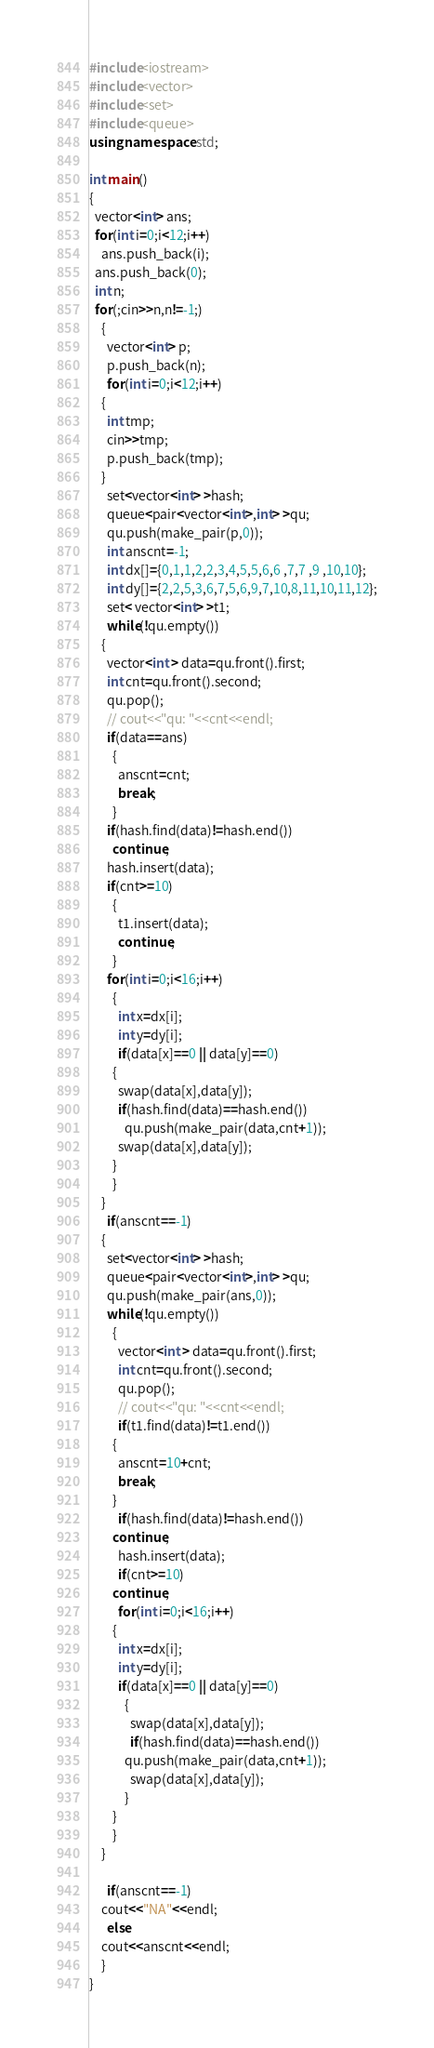<code> <loc_0><loc_0><loc_500><loc_500><_C++_>#include<iostream>
#include<vector>
#include<set>
#include<queue>
using namespace std;

int main()
{
  vector<int> ans;
  for(int i=0;i<12;i++)
    ans.push_back(i);
  ans.push_back(0);
  int n;
  for(;cin>>n,n!=-1;)
    {
      vector<int> p;
      p.push_back(n);
      for(int i=0;i<12;i++)
	{
	  int tmp;
	  cin>>tmp;
	  p.push_back(tmp);
	}
      set<vector<int> >hash;
      queue<pair<vector<int>,int> >qu;
      qu.push(make_pair(p,0));
      int anscnt=-1;
      int dx[]={0,1,1,2,2,3,4,5,5,6,6 ,7,7 ,9 ,10,10};
      int dy[]={2,2,5,3,6,7,5,6,9,7,10,8,11,10,11,12};
      set< vector<int> >t1;
      while(!qu.empty())
	{
	  vector<int > data=qu.front().first;
	  int cnt=qu.front().second;
	  qu.pop();
	  // cout<<"qu: "<<cnt<<endl;
	  if(data==ans)
	    {
	      anscnt=cnt;
	      break;
	    }
	  if(hash.find(data)!=hash.end())
	    continue;
	  hash.insert(data);
	  if(cnt>=10)
	    {
	      t1.insert(data);
	      continue;
	    }
	  for(int i=0;i<16;i++)
	    {
	      int x=dx[i];
	      int y=dy[i];
	      if(data[x]==0 || data[y]==0)
		{
		  swap(data[x],data[y]);
		  if(hash.find(data)==hash.end())
		    qu.push(make_pair(data,cnt+1));
		  swap(data[x],data[y]);
		}
	    }
	}
      if(anscnt==-1)
	{
	  set<vector<int> >hash;
	  queue<pair<vector<int>,int> >qu;
	  qu.push(make_pair(ans,0));
	  while(!qu.empty())
	    {
	      vector<int > data=qu.front().first;
	      int cnt=qu.front().second;
	      qu.pop();
	      // cout<<"qu: "<<cnt<<endl;
	      if(t1.find(data)!=t1.end())
		{
		  anscnt=10+cnt;
		  break;
		}
	      if(hash.find(data)!=hash.end())
		continue;
	      hash.insert(data);
	      if(cnt>=10)
		continue;
	      for(int i=0;i<16;i++)
		{
		  int x=dx[i];
		  int y=dy[i];
		  if(data[x]==0 || data[y]==0)
		    {
		      swap(data[x],data[y]);
		      if(hash.find(data)==hash.end())
			qu.push(make_pair(data,cnt+1));
		      swap(data[x],data[y]);
		    }
		}
	    }
	}

      if(anscnt==-1)
	cout<<"NA"<<endl;
      else
	cout<<anscnt<<endl;
    }
}</code> 